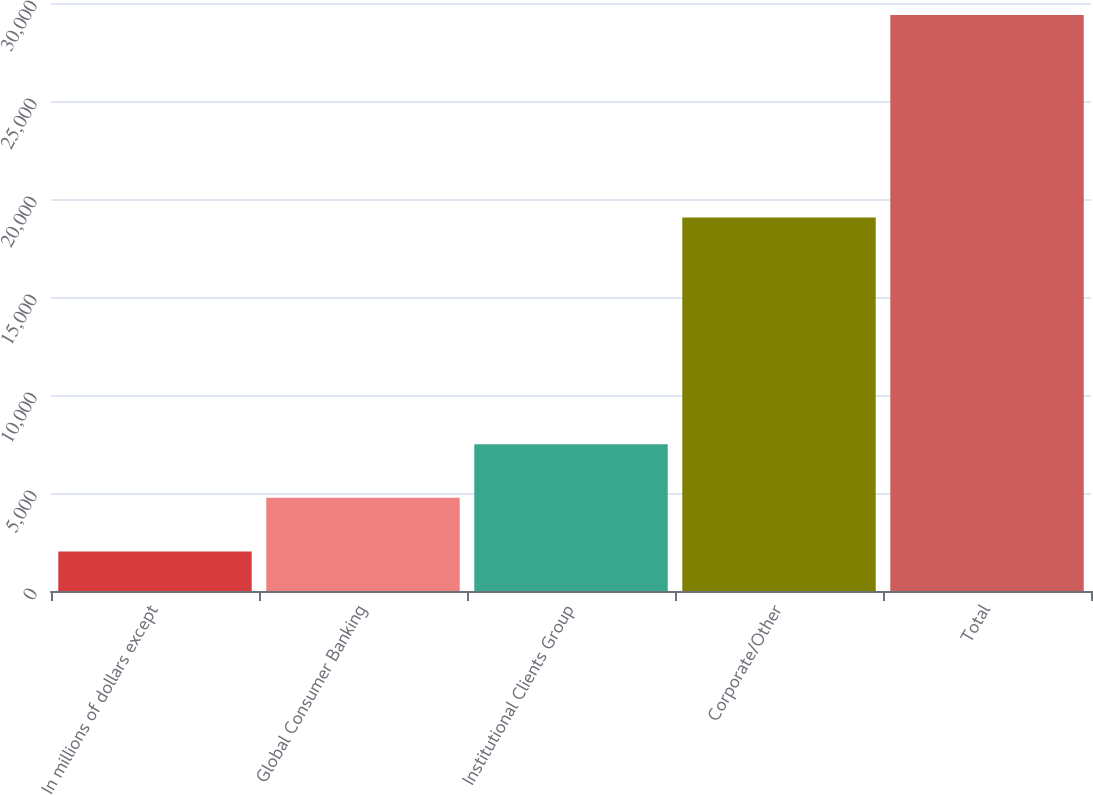Convert chart to OTSL. <chart><loc_0><loc_0><loc_500><loc_500><bar_chart><fcel>In millions of dollars except<fcel>Global Consumer Banking<fcel>Institutional Clients Group<fcel>Corporate/Other<fcel>Total<nl><fcel>2017<fcel>4754.1<fcel>7491.2<fcel>19060<fcel>29388<nl></chart> 